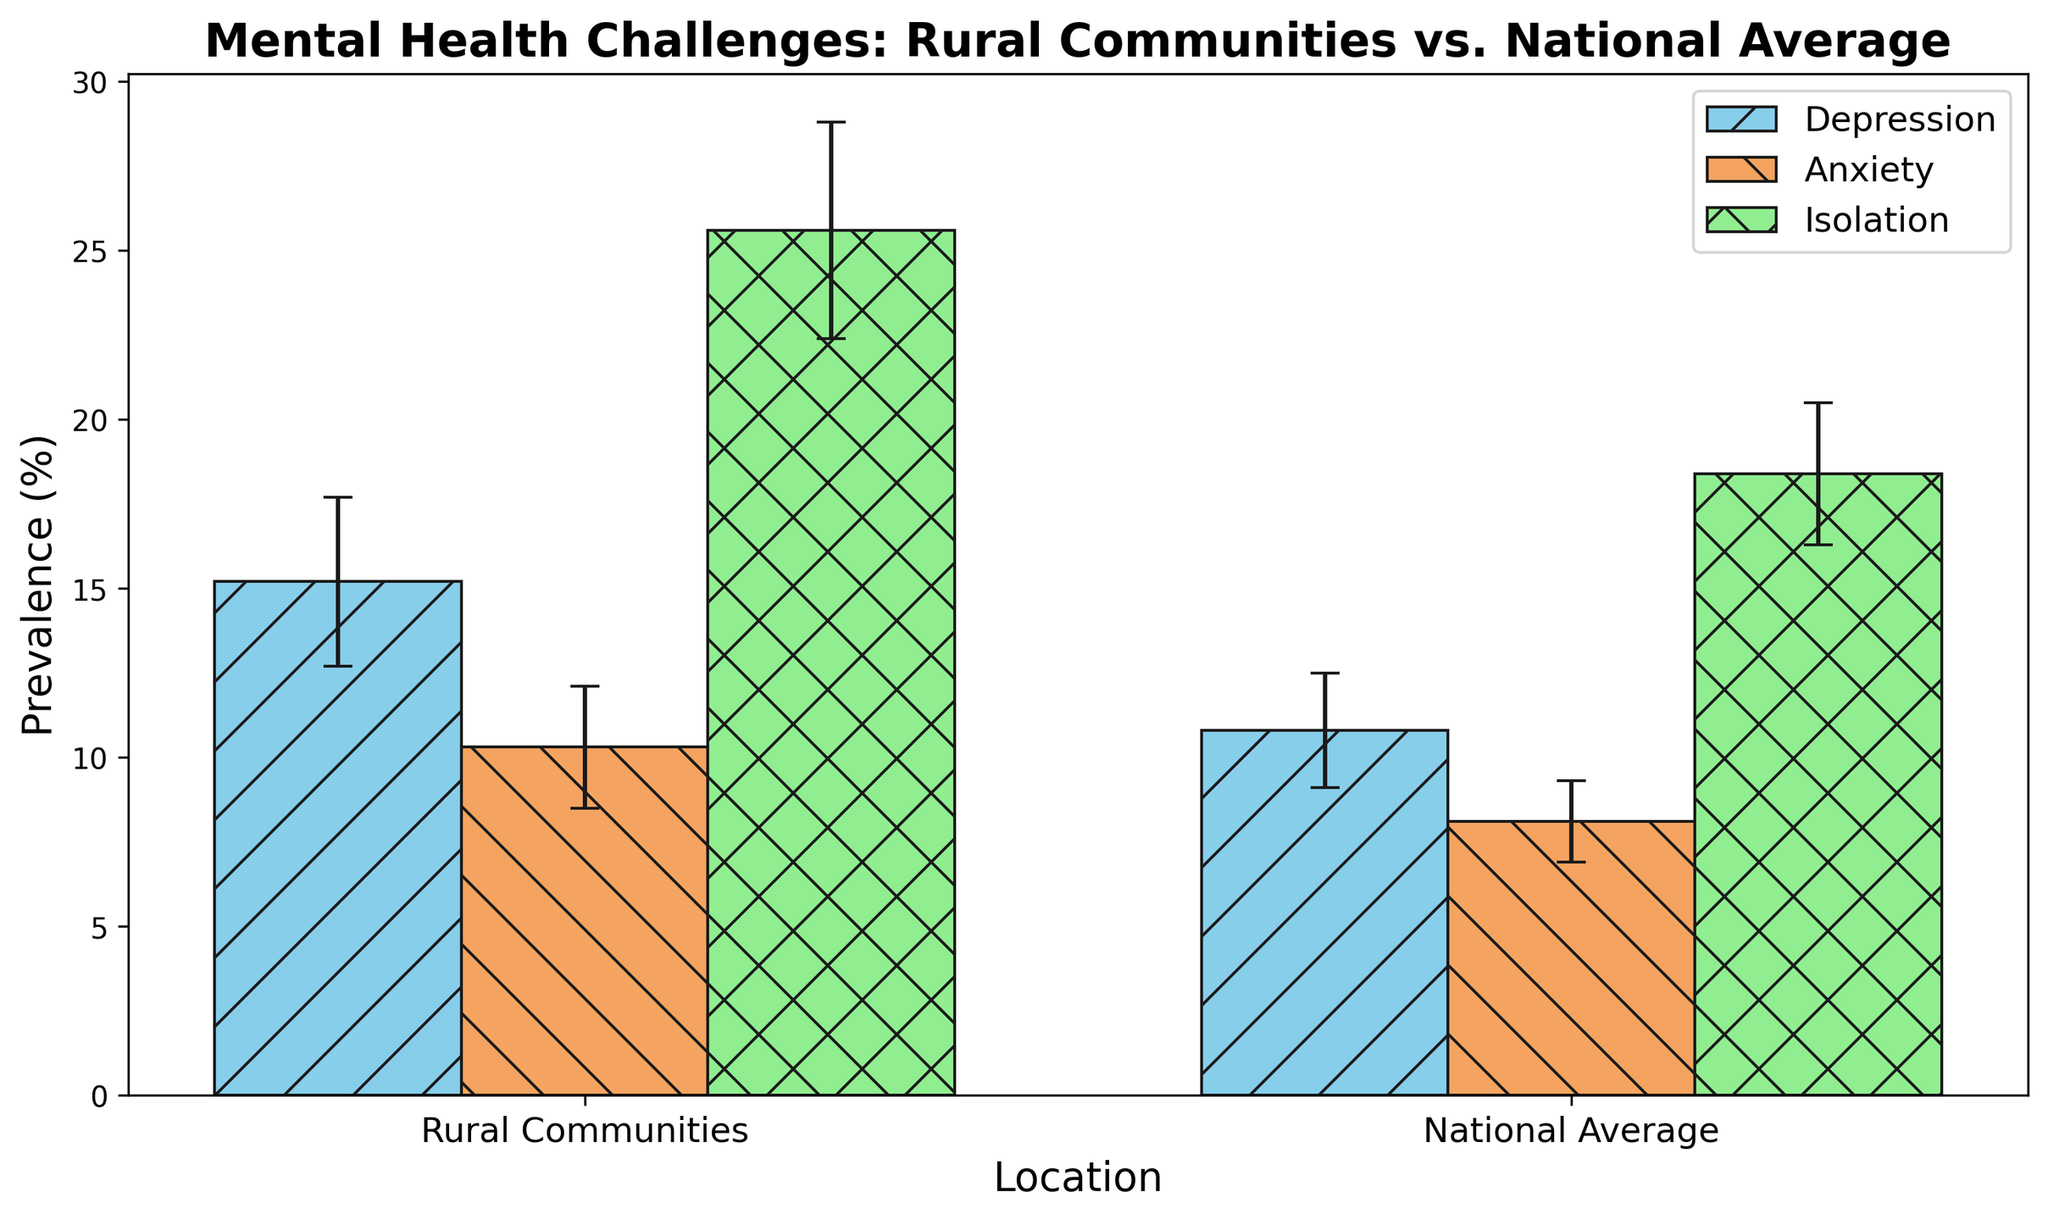What's the difference in the prevalence of depression between rural communities and the national average? To find the difference, subtract the national average prevalence (10.8%) from the rural communities prevalence (15.2%): 15.2% - 10.8% = 4.4%.
Answer: 4.4% Which mental health challenge has the largest difference in prevalence between rural communities and the national average? Calculate the differences for depression (15.2% - 10.8% = 4.4%), anxiety (10.3% - 8.1% = 2.2%), and isolation (25.6% - 18.4% = 7.2%). The largest difference is for isolation (7.2%).
Answer: Isolation What is the combined prevalence of anxiety and depression in rural communities? Add the prevalence of anxiety (10.3%) and the prevalence of depression (15.2%) in rural communities: 10.3% + 15.2% = 25.5%.
Answer: 25.5% Which category shows the smallest standard deviation in the national average data? Compare the standard deviations for depression (1.7%), anxiety (1.2%), and isolation (2.1%) in the national average. The smallest standard deviation is for anxiety (1.2%).
Answer: Anxiety How much higher is the prevalence of isolation in rural communities compared to the national average? Subtract the national average prevalence of isolation (18.4%) from the rural communities prevalence (25.6%): 25.6% - 18.4% = 7.2%.
Answer: 7.2% Which color-coded bar represents the highest prevalence among all categories? Identify the tallest bar among the categories. The isolation bar in rural communities (colored light green) is the tallest at 25.6%.
Answer: Isolation (light green) What is the average standard deviation of mental health challenges in rural communities? Sum the standard deviations of depression (2.5%), anxiety (1.8%), and isolation (3.2%) and divide by 3: (2.5% + 1.8% + 3.2%) / 3 = 2.5%.
Answer: 2.5% Is the prevalence of anxiety higher in rural communities or in the national average? Compare the prevalence of anxiety in rural communities (10.3%) to the national average (8.1%). The rural communities have a higher prevalence.
Answer: Rural communities What is the ratio of the prevalence of isolation to anxiety in the national average? Divide the prevalence of isolation (18.4%) by the prevalence of anxiety (8.1%) in the national average: 18.4 / 8.1 ≈ 2.27.
Answer: 2.27 Which mental health challenge has the largest standard deviation in rural communities? Compare the standard deviations for depression (2.5%), anxiety (1.8%), and isolation (3.2%) in rural communities. The largest standard deviation is for isolation (3.2%).
Answer: Isolation 